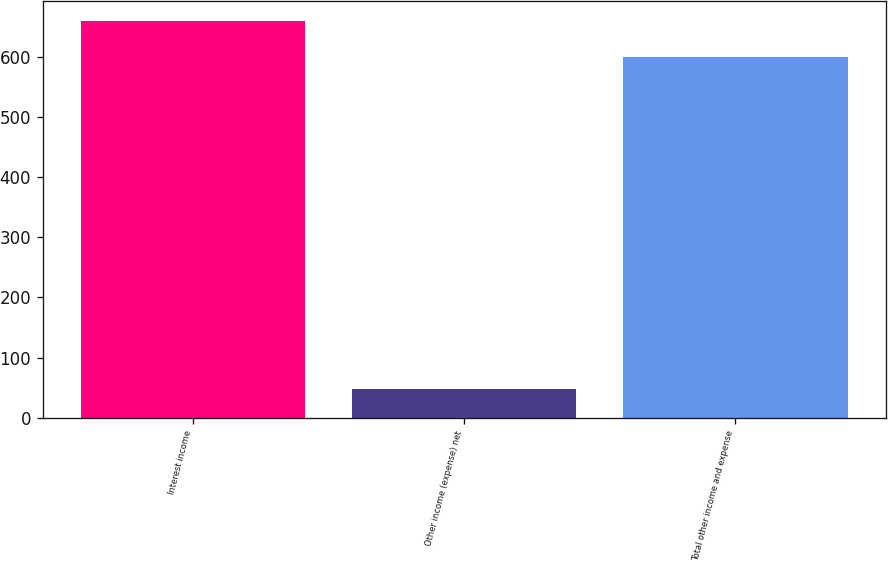Convert chart to OTSL. <chart><loc_0><loc_0><loc_500><loc_500><bar_chart><fcel>Interest income<fcel>Other income (expense) net<fcel>Total other income and expense<nl><fcel>658.9<fcel>48<fcel>599<nl></chart> 